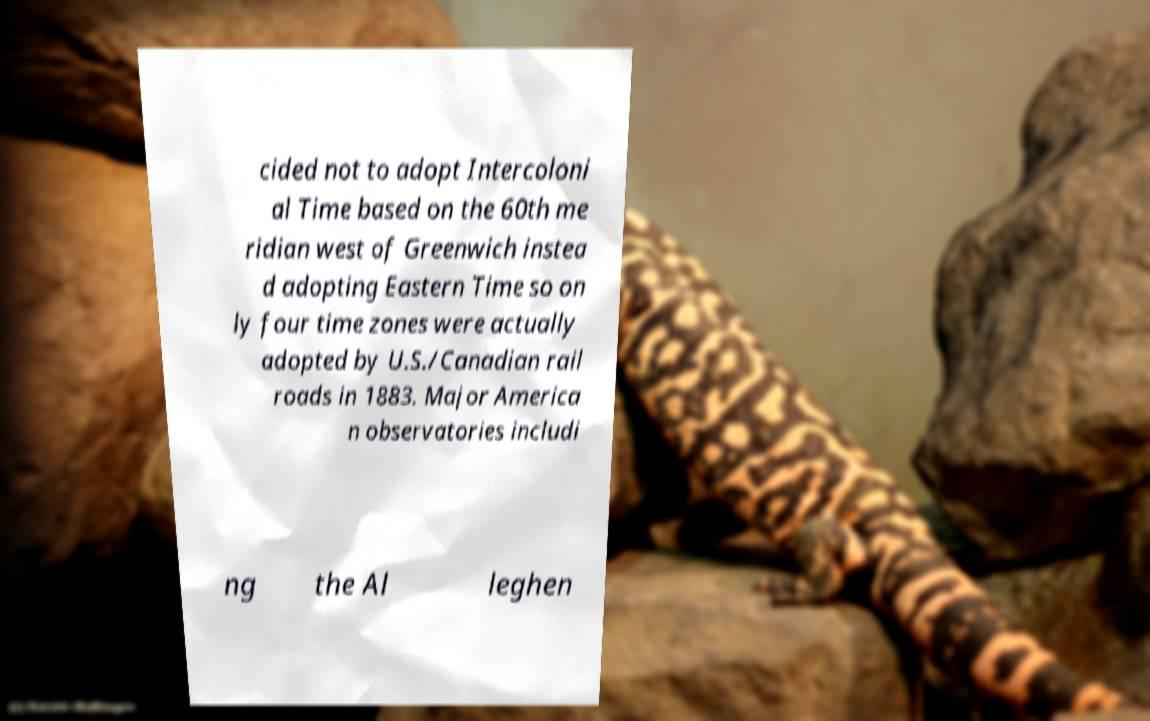Could you extract and type out the text from this image? cided not to adopt Intercoloni al Time based on the 60th me ridian west of Greenwich instea d adopting Eastern Time so on ly four time zones were actually adopted by U.S./Canadian rail roads in 1883. Major America n observatories includi ng the Al leghen 